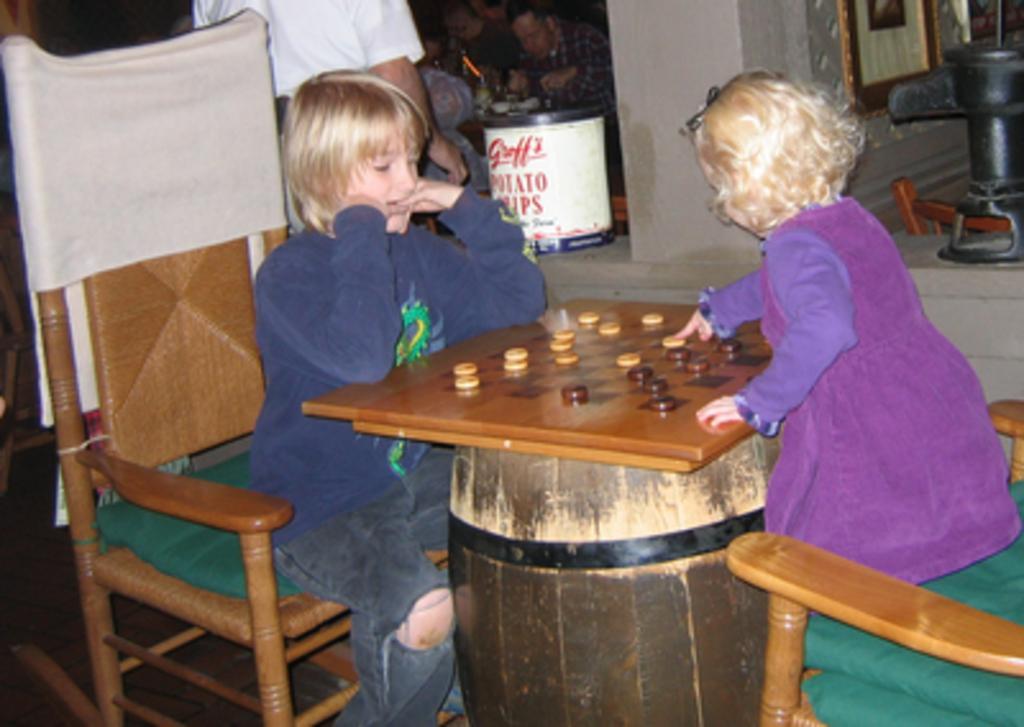Describe this image in one or two sentences. In this image i can see two children playing a game at the back ground i can see a man standing, a bin and a wall. 